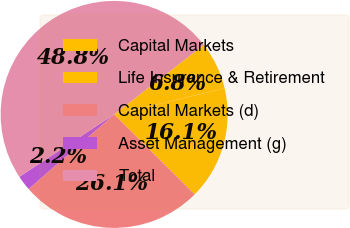Convert chart to OTSL. <chart><loc_0><loc_0><loc_500><loc_500><pie_chart><fcel>Capital Markets<fcel>Life Insurance & Retirement<fcel>Capital Markets (d)<fcel>Asset Management (g)<fcel>Total<nl><fcel>6.81%<fcel>16.13%<fcel>26.14%<fcel>2.15%<fcel>48.77%<nl></chart> 